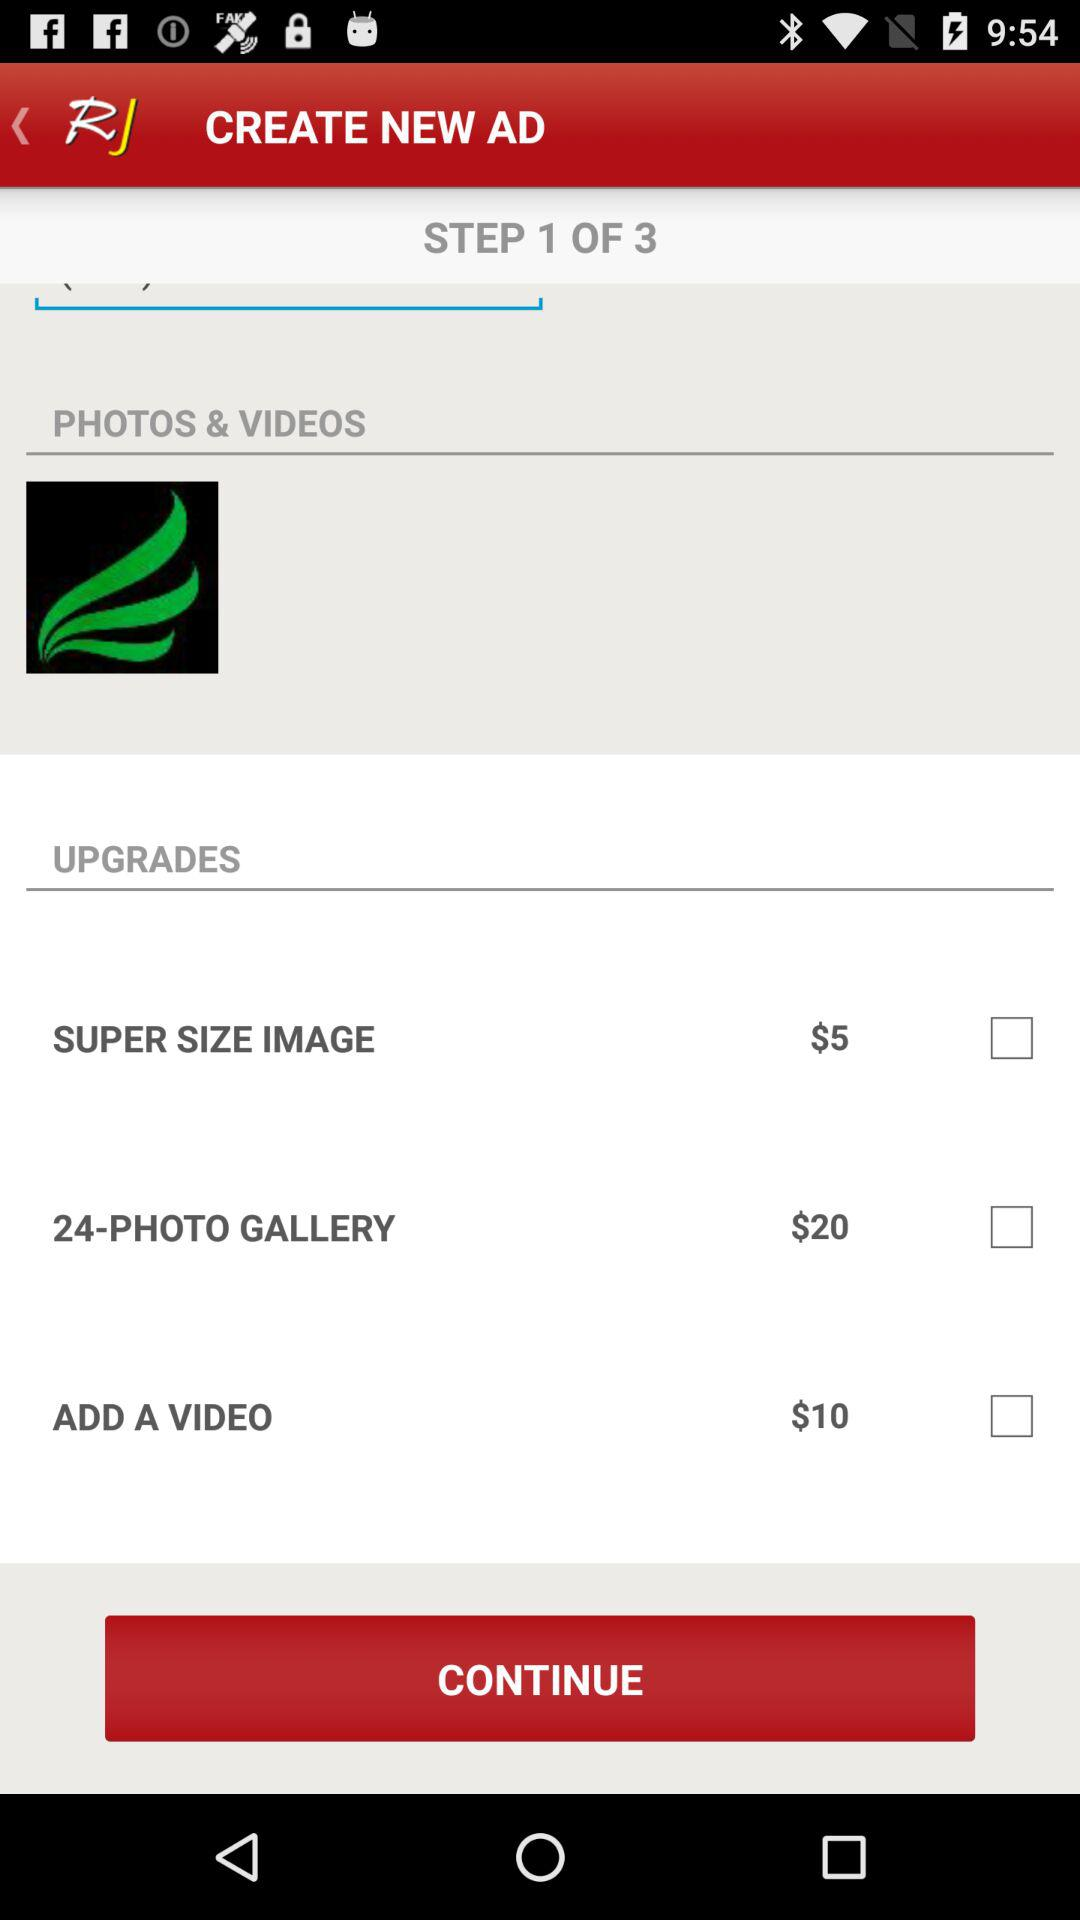How many upgrades are there in total?
Answer the question using a single word or phrase. 3 